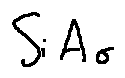<formula> <loc_0><loc_0><loc_500><loc_500>S i A _ { \sigma }</formula> 